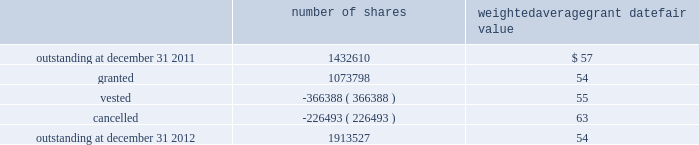The weighted average grant date fair value of options granted during 2012 , 2011 , and 2010 was $ 13 , $ 19 and $ 20 per share , respectively .
The total intrinsic value of options exercised during the years ended december 31 , 2012 , 2011 and 2010 , was $ 19.0 million , $ 4.2 million and $ 15.6 million , respectively .
In 2012 , the company granted 931340 shares of restricted class a common stock and 4048 shares of restricted stock units .
Restricted common stock and restricted stock units generally have a vesting period of 2 to 4 years .
The fair value related to these grants was $ 54.5 million , which is recognized as compensation expense on an accelerated basis over the vesting period .
Beginning with restricted stock grants in september 2010 , dividends are accrued on restricted class a common stock and restricted stock units and are paid once the restricted stock vests .
In 2012 , the company also granted 138410 performance shares .
The fair value related to these grants was $ 7.7 million , which is recognized as compensation expense on an accelerated and straight-lined basis over the vesting period .
The vesting of these shares is contingent on meeting stated performance or market conditions .
The table summarizes restricted stock , restricted stock units , and performance shares activity for 2012 : number of shares weighted average grant date fair value outstanding at december 31 , 2011 .
1432610 $ 57 .
Outstanding at december 31 , 2012 .
1913527 54 the total fair value of restricted stock , restricted stock units , and performance shares that vested during the years ended december 31 , 2012 , 2011 and 2010 , was $ 20.9 million , $ 11.6 million and $ 10.3 million , respectively .
Eligible employees may acquire shares of class a common stock using after-tax payroll deductions made during consecutive offering periods of approximately six months in duration .
Shares are purchased at the end of each offering period at a price of 90% ( 90 % ) of the closing price of the class a common stock as reported on the nasdaq global select market .
Compensation expense is recognized on the dates of purchase for the discount from the closing price .
In 2012 , 2011 and 2010 , a total of 27768 , 32085 and 21855 shares , respectively , of class a common stock were issued to participating employees .
These shares are subject to a six-month holding period .
Annual expense of $ 0.1 million , $ 0.2 million and $ 0.1 million for the purchase discount was recognized in 2012 , 2011 and 2010 , respectively .
Non-executive directors receive an annual award of class a common stock with a value equal to $ 75000 .
Non-executive directors may also elect to receive some or all of the cash portion of their annual stipend , up to $ 25000 , in shares of stock based on the closing price at the date of distribution .
As a result , 40260 , 40585 and 37350 shares of class a common stock were issued to non-executive directors during 2012 , 2011 and 2010 , respectively .
These shares are not subject to any vesting restrictions .
Expense of $ 2.2 million , $ 2.1 million and $ 2.4 million related to these stock-based payments was recognized for the years ended december 31 , 2012 , 2011 and 2010 , respectively .
19 .
Fair value measurements in general , the company uses quoted prices in active markets for identical assets to determine the fair value of marketable securities and equity investments .
Level 1 assets generally include u.s .
Treasury securities , equity securities listed in active markets , and investments in publicly traded mutual funds with quoted market prices .
If quoted prices are not available to determine fair value , the company uses other inputs that are directly observable .
Assets included in level 2 generally consist of asset- backed securities , municipal bonds , u.s .
Government agency securities and interest rate swap contracts .
Asset-backed securities , municipal bonds and u.s .
Government agency securities were measured at fair value based on matrix pricing using prices of similar securities with similar inputs such as maturity dates , interest rates and credit ratings .
The company determined the fair value of its interest rate swap contracts using standard valuation models with market-based observable inputs including forward and spot exchange rates and interest rate curves. .
In 2012 what was the percentage increase in the number of shares outstanding? 
Computations: ((1913527 / 1432610) / 1432610)
Answer: 0.0. 